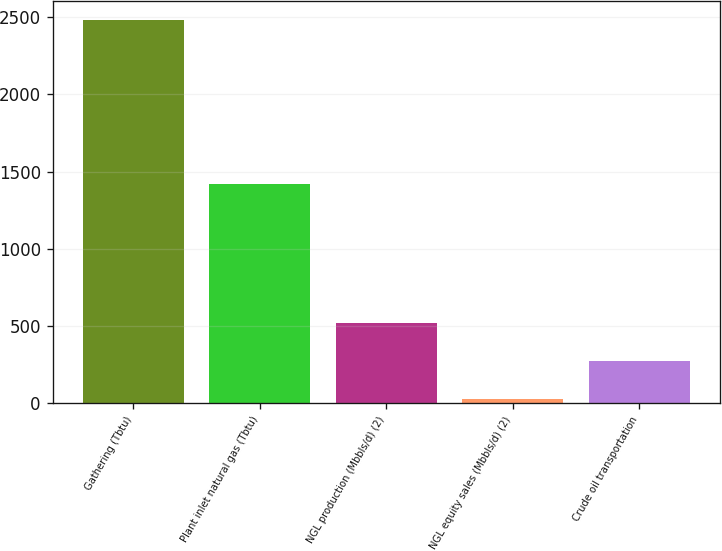Convert chart. <chart><loc_0><loc_0><loc_500><loc_500><bar_chart><fcel>Gathering (Tbtu)<fcel>Plant inlet natural gas (Tbtu)<fcel>NGL production (Mbbls/d) (2)<fcel>NGL equity sales (Mbbls/d) (2)<fcel>Crude oil transportation<nl><fcel>2482<fcel>1419<fcel>518<fcel>27<fcel>272.5<nl></chart> 